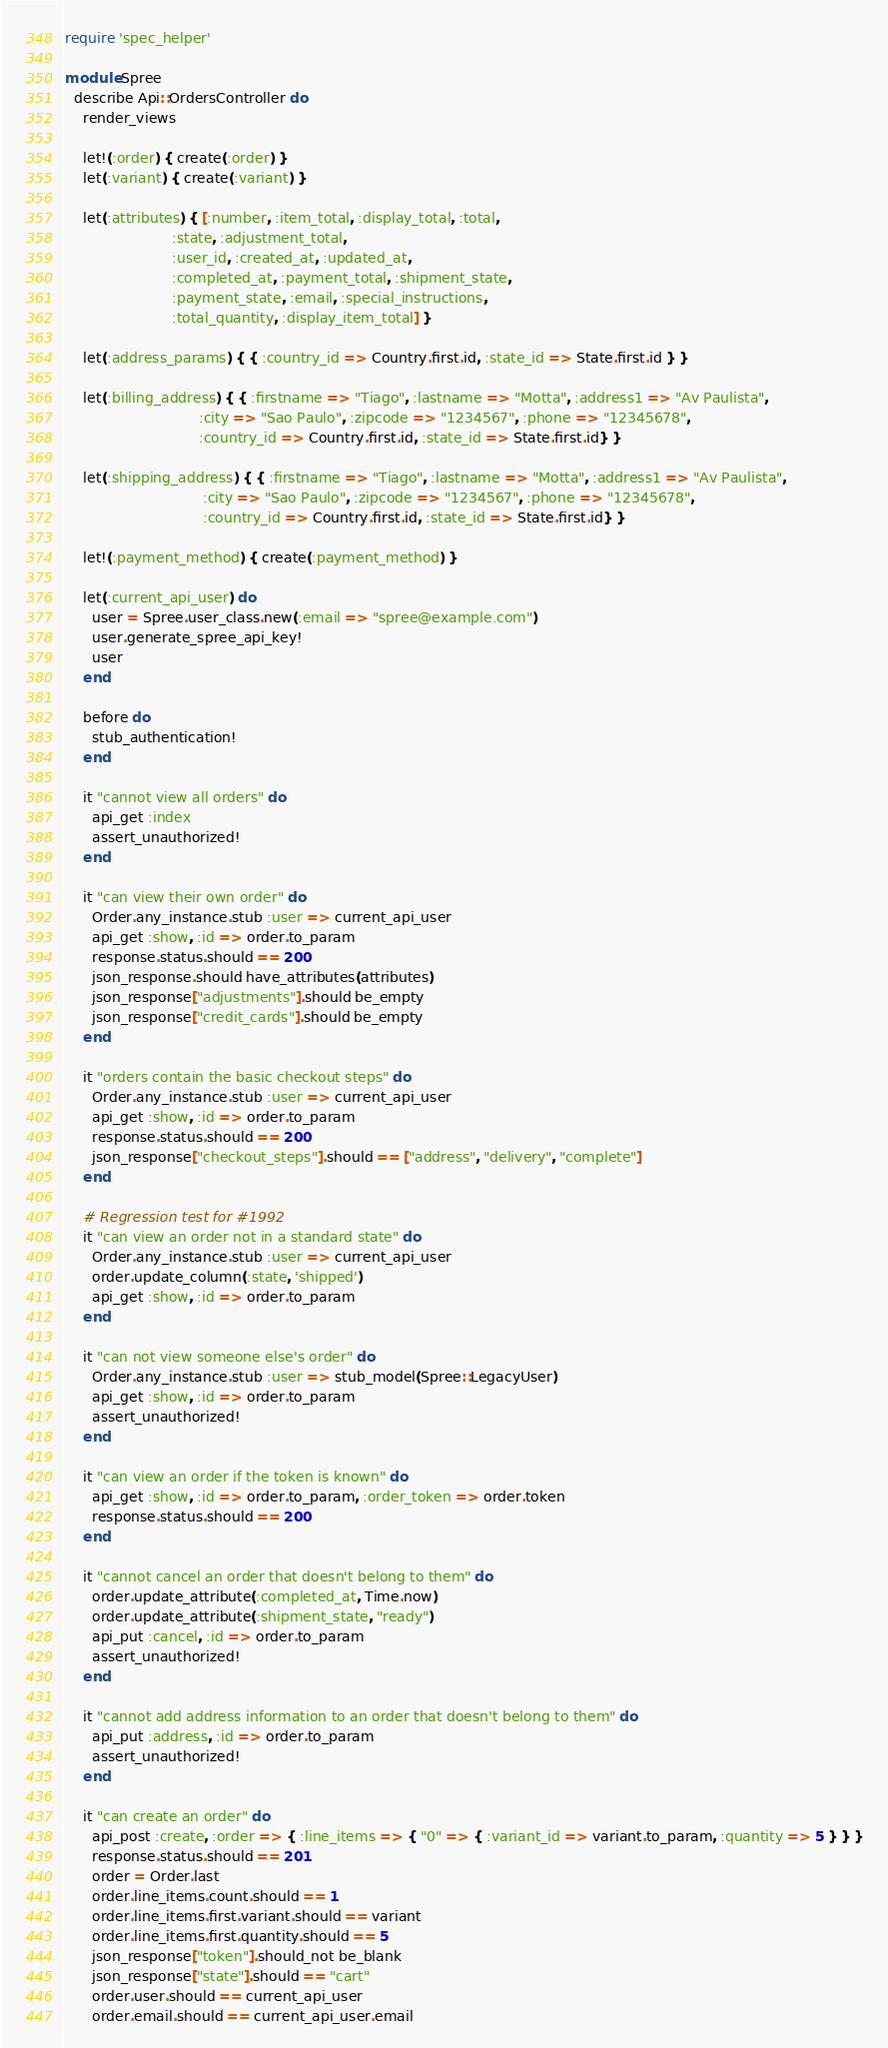<code> <loc_0><loc_0><loc_500><loc_500><_Ruby_>require 'spec_helper'

module Spree
  describe Api::OrdersController do
    render_views

    let!(:order) { create(:order) }
    let(:variant) { create(:variant) }

    let(:attributes) { [:number, :item_total, :display_total, :total,
                        :state, :adjustment_total,
                        :user_id, :created_at, :updated_at,
                        :completed_at, :payment_total, :shipment_state,
                        :payment_state, :email, :special_instructions,
                        :total_quantity, :display_item_total] }

    let(:address_params) { { :country_id => Country.first.id, :state_id => State.first.id } }

    let(:billing_address) { { :firstname => "Tiago", :lastname => "Motta", :address1 => "Av Paulista",
                              :city => "Sao Paulo", :zipcode => "1234567", :phone => "12345678",
                              :country_id => Country.first.id, :state_id => State.first.id} }

    let(:shipping_address) { { :firstname => "Tiago", :lastname => "Motta", :address1 => "Av Paulista",
                               :city => "Sao Paulo", :zipcode => "1234567", :phone => "12345678",
                               :country_id => Country.first.id, :state_id => State.first.id} }

    let!(:payment_method) { create(:payment_method) }

    let(:current_api_user) do
      user = Spree.user_class.new(:email => "spree@example.com")
      user.generate_spree_api_key!
      user
    end

    before do
      stub_authentication!
    end

    it "cannot view all orders" do
      api_get :index
      assert_unauthorized!
    end

    it "can view their own order" do
      Order.any_instance.stub :user => current_api_user
      api_get :show, :id => order.to_param
      response.status.should == 200
      json_response.should have_attributes(attributes)
      json_response["adjustments"].should be_empty
      json_response["credit_cards"].should be_empty
    end

    it "orders contain the basic checkout steps" do
      Order.any_instance.stub :user => current_api_user
      api_get :show, :id => order.to_param
      response.status.should == 200
      json_response["checkout_steps"].should == ["address", "delivery", "complete"]
    end

    # Regression test for #1992
    it "can view an order not in a standard state" do
      Order.any_instance.stub :user => current_api_user
      order.update_column(:state, 'shipped')
      api_get :show, :id => order.to_param
    end

    it "can not view someone else's order" do
      Order.any_instance.stub :user => stub_model(Spree::LegacyUser)
      api_get :show, :id => order.to_param
      assert_unauthorized!
    end

    it "can view an order if the token is known" do
      api_get :show, :id => order.to_param, :order_token => order.token
      response.status.should == 200
    end

    it "cannot cancel an order that doesn't belong to them" do
      order.update_attribute(:completed_at, Time.now)
      order.update_attribute(:shipment_state, "ready")
      api_put :cancel, :id => order.to_param
      assert_unauthorized!
    end

    it "cannot add address information to an order that doesn't belong to them" do
      api_put :address, :id => order.to_param
      assert_unauthorized!
    end

    it "can create an order" do
      api_post :create, :order => { :line_items => { "0" => { :variant_id => variant.to_param, :quantity => 5 } } }
      response.status.should == 201
      order = Order.last
      order.line_items.count.should == 1
      order.line_items.first.variant.should == variant
      order.line_items.first.quantity.should == 5
      json_response["token"].should_not be_blank
      json_response["state"].should == "cart"
      order.user.should == current_api_user
      order.email.should == current_api_user.email</code> 